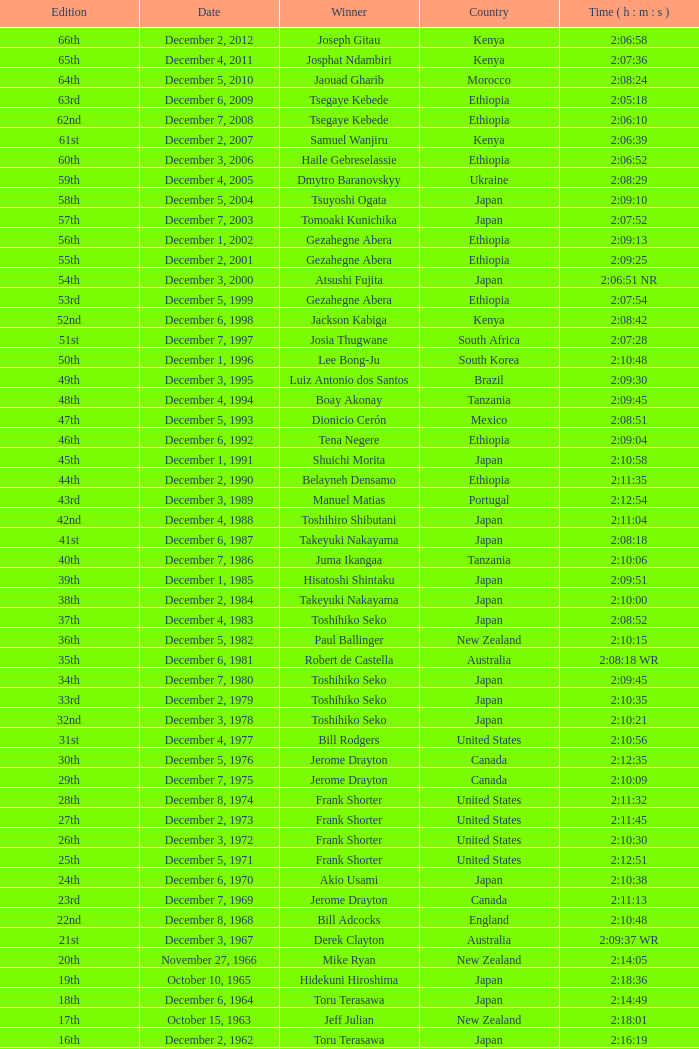Who emerged victorious in the 23rd edition? Jerome Drayton. 